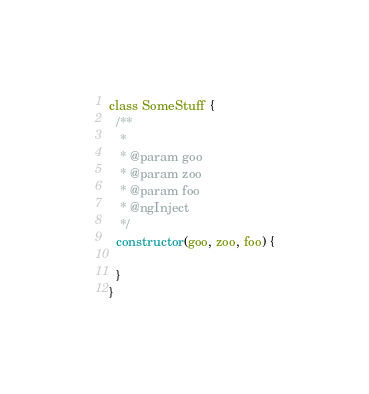<code> <loc_0><loc_0><loc_500><loc_500><_JavaScript_>class SomeStuff {
  /**
   *
   * @param goo
   * @param zoo
   * @param foo
   * @ngInject
   */
  constructor(goo, zoo, foo) {

  }
}
</code> 